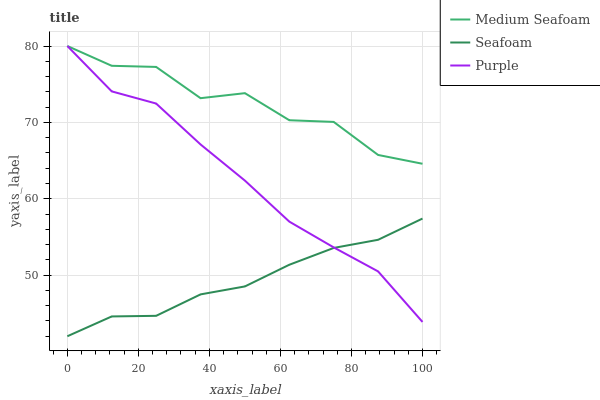Does Medium Seafoam have the minimum area under the curve?
Answer yes or no. No. Does Seafoam have the maximum area under the curve?
Answer yes or no. No. Is Medium Seafoam the smoothest?
Answer yes or no. No. Is Seafoam the roughest?
Answer yes or no. No. Does Medium Seafoam have the lowest value?
Answer yes or no. No. Does Seafoam have the highest value?
Answer yes or no. No. Is Seafoam less than Medium Seafoam?
Answer yes or no. Yes. Is Medium Seafoam greater than Seafoam?
Answer yes or no. Yes. Does Seafoam intersect Medium Seafoam?
Answer yes or no. No. 